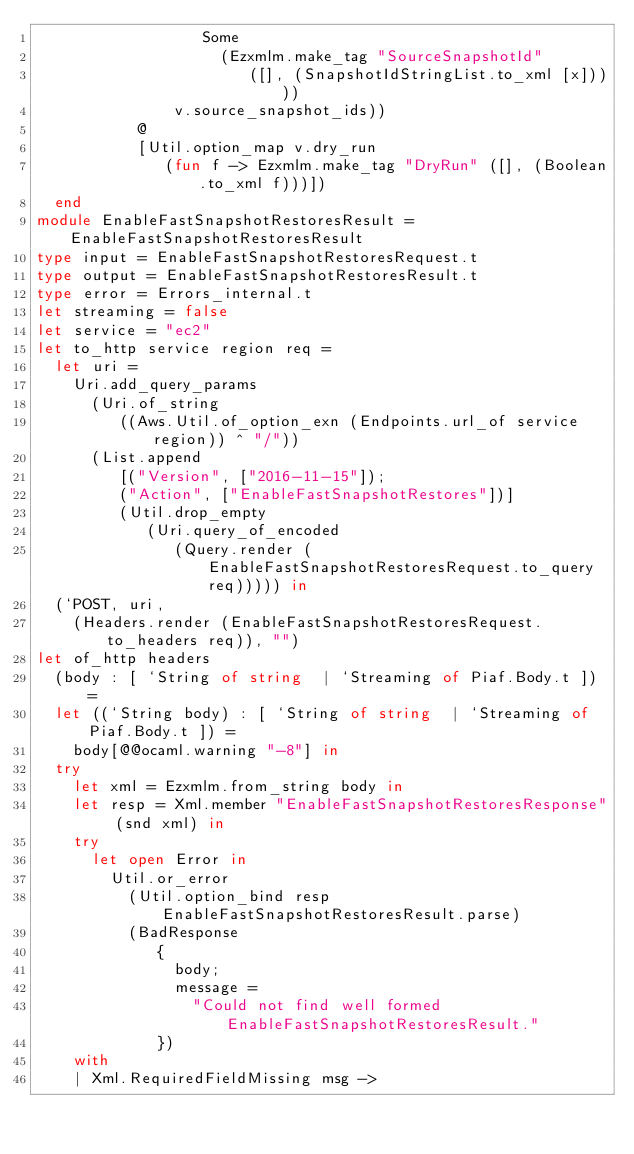Convert code to text. <code><loc_0><loc_0><loc_500><loc_500><_OCaml_>                  Some
                    (Ezxmlm.make_tag "SourceSnapshotId"
                       ([], (SnapshotIdStringList.to_xml [x]))))
               v.source_snapshot_ids))
           @
           [Util.option_map v.dry_run
              (fun f -> Ezxmlm.make_tag "DryRun" ([], (Boolean.to_xml f)))])
  end
module EnableFastSnapshotRestoresResult = EnableFastSnapshotRestoresResult
type input = EnableFastSnapshotRestoresRequest.t
type output = EnableFastSnapshotRestoresResult.t
type error = Errors_internal.t
let streaming = false
let service = "ec2"
let to_http service region req =
  let uri =
    Uri.add_query_params
      (Uri.of_string
         ((Aws.Util.of_option_exn (Endpoints.url_of service region)) ^ "/"))
      (List.append
         [("Version", ["2016-11-15"]);
         ("Action", ["EnableFastSnapshotRestores"])]
         (Util.drop_empty
            (Uri.query_of_encoded
               (Query.render (EnableFastSnapshotRestoresRequest.to_query req))))) in
  (`POST, uri,
    (Headers.render (EnableFastSnapshotRestoresRequest.to_headers req)), "")
let of_http headers
  (body : [ `String of string  | `Streaming of Piaf.Body.t ]) =
  let ((`String body) : [ `String of string  | `Streaming of Piaf.Body.t ]) =
    body[@@ocaml.warning "-8"] in
  try
    let xml = Ezxmlm.from_string body in
    let resp = Xml.member "EnableFastSnapshotRestoresResponse" (snd xml) in
    try
      let open Error in
        Util.or_error
          (Util.option_bind resp EnableFastSnapshotRestoresResult.parse)
          (BadResponse
             {
               body;
               message =
                 "Could not find well formed EnableFastSnapshotRestoresResult."
             })
    with
    | Xml.RequiredFieldMissing msg -></code> 